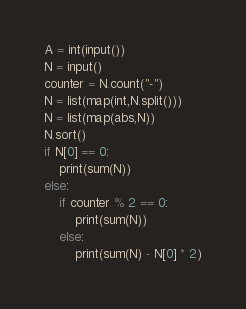<code> <loc_0><loc_0><loc_500><loc_500><_Python_>A = int(input())
N = input()
counter = N.count("-")
N = list(map(int,N.split()))
N = list(map(abs,N))
N.sort()
if N[0] == 0:
    print(sum(N))
else:
    if counter % 2 == 0:
        print(sum(N))
    else:
        print(sum(N) - N[0] * 2)</code> 